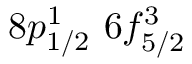Convert formula to latex. <formula><loc_0><loc_0><loc_500><loc_500>8 p _ { 1 / 2 } ^ { 1 } \, 6 f _ { 5 / 2 } ^ { 3 }</formula> 